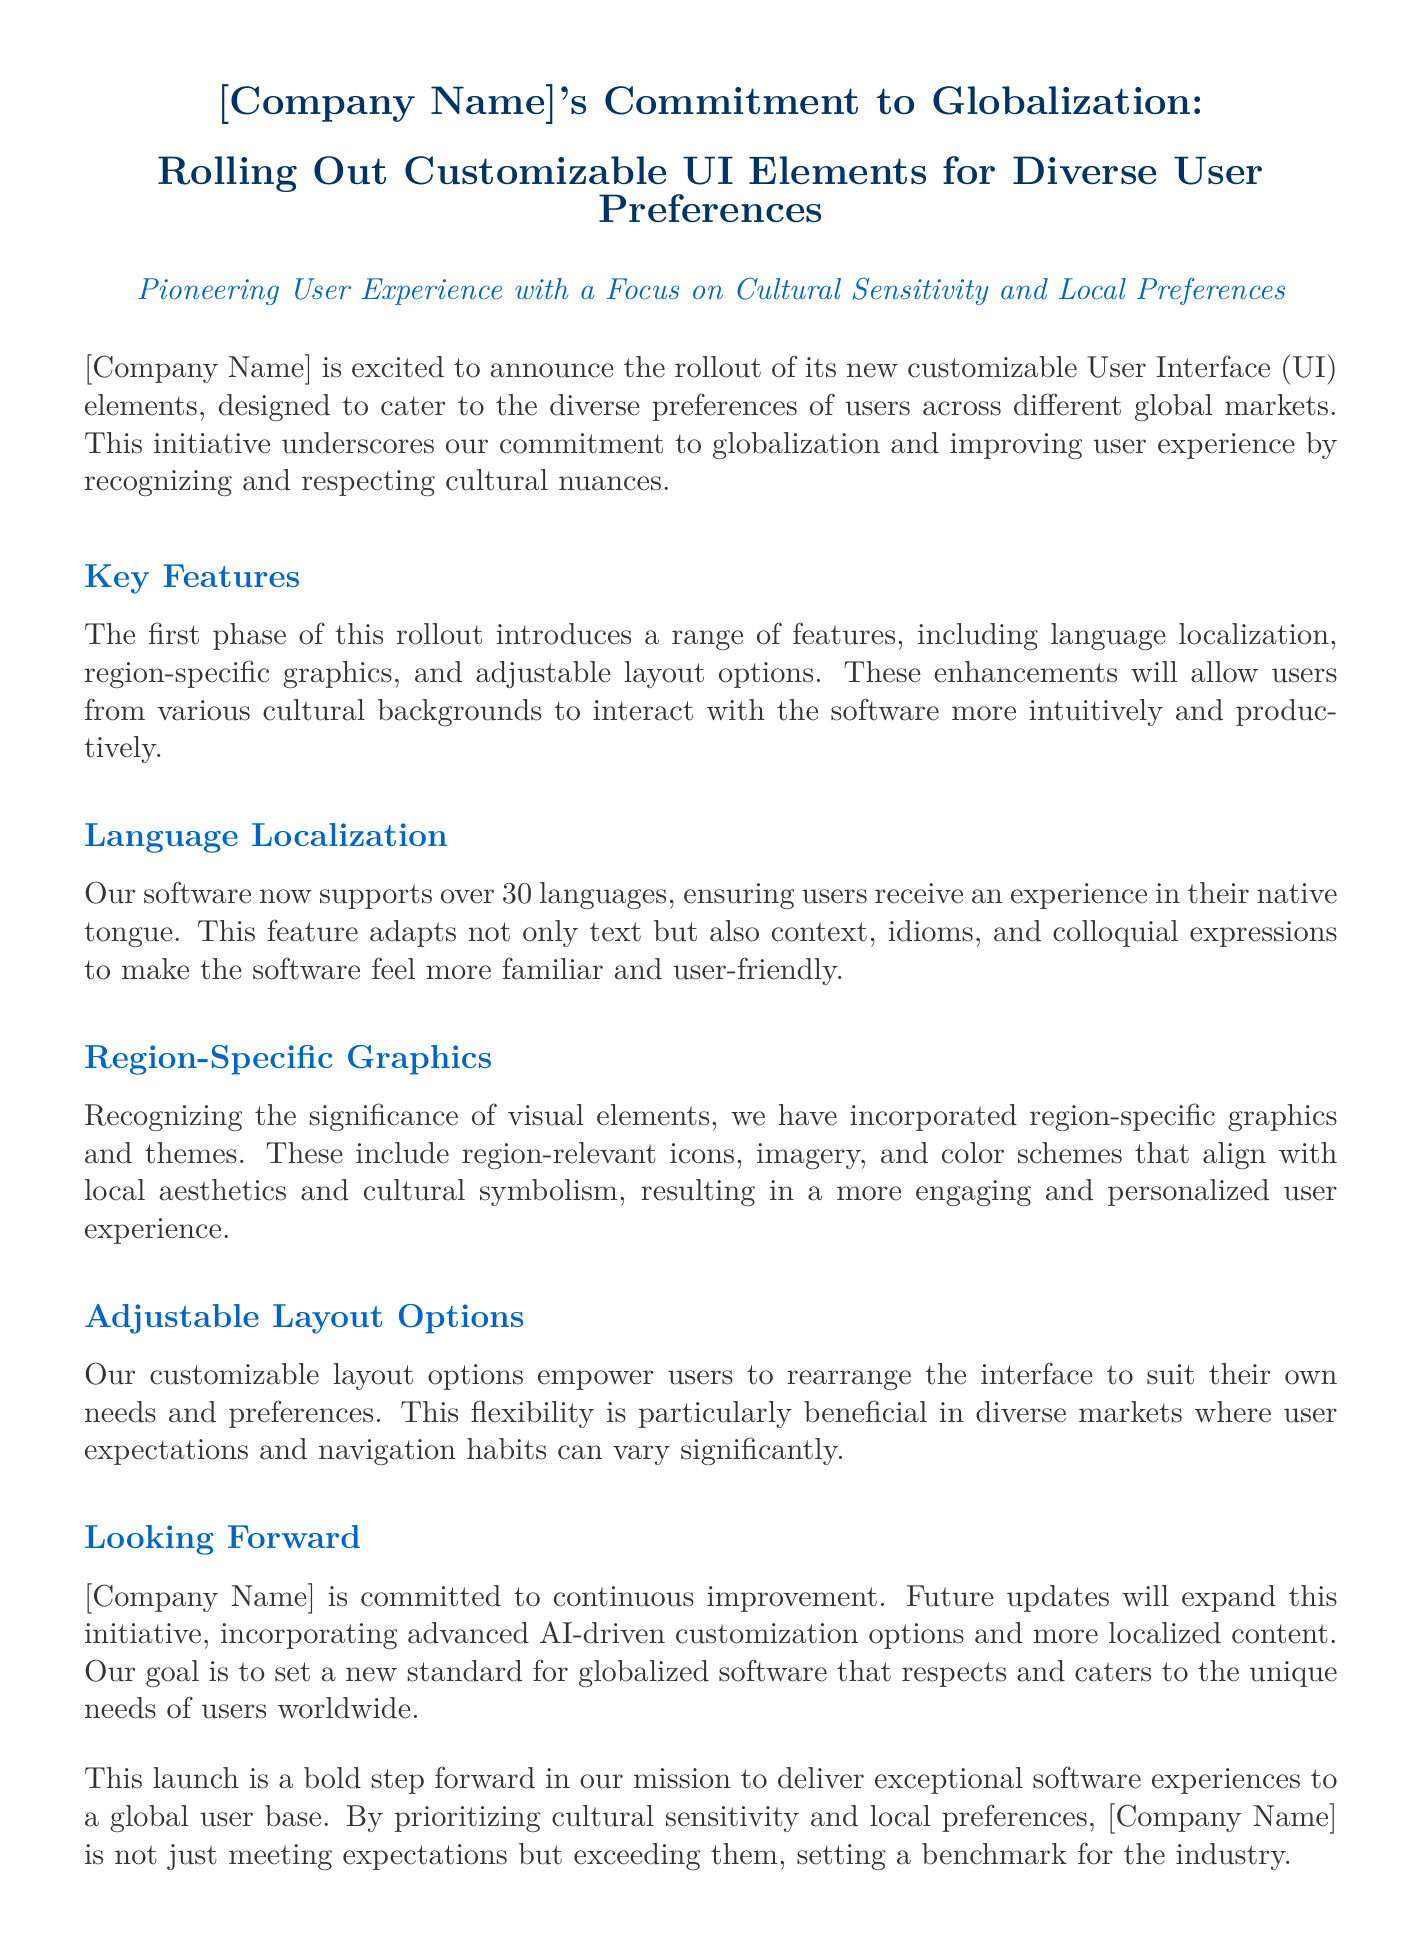What is the title of the press release? The title of the press release highlights the company's commitment to globalization and the rollout of customizable UI elements.
Answer: [Company Name]'s Commitment to Globalization: Rolling Out Customizable UI Elements for Diverse User Preferences How many languages does the software support? The document states that the software now supports over 30 languages for user experience.
Answer: over 30 languages What is one key feature mentioned in the press release? The press release identifies several features but asks for one, such as language localization.
Answer: language localization Who is the head of Global Communications? The press release provides the name and title of the media contact for inquiries.
Answer: Jane Doe What future updates are mentioned in the document? The document outlines that future updates will incorporate advanced AI-driven customization options.
Answer: advanced AI-driven customization options What is the goal of the software enhancements? The enhancements aim to deliver a more engaging and productive user experience reflecting local preferences.
Answer: user experience In how many countries does the company have a presence? The document specifies that the company operates in a significant number of countries, precisely.
Answer: over 50 countries 